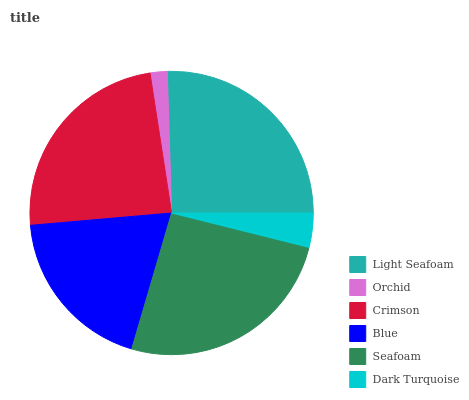Is Orchid the minimum?
Answer yes or no. Yes. Is Seafoam the maximum?
Answer yes or no. Yes. Is Crimson the minimum?
Answer yes or no. No. Is Crimson the maximum?
Answer yes or no. No. Is Crimson greater than Orchid?
Answer yes or no. Yes. Is Orchid less than Crimson?
Answer yes or no. Yes. Is Orchid greater than Crimson?
Answer yes or no. No. Is Crimson less than Orchid?
Answer yes or no. No. Is Crimson the high median?
Answer yes or no. Yes. Is Blue the low median?
Answer yes or no. Yes. Is Light Seafoam the high median?
Answer yes or no. No. Is Seafoam the low median?
Answer yes or no. No. 